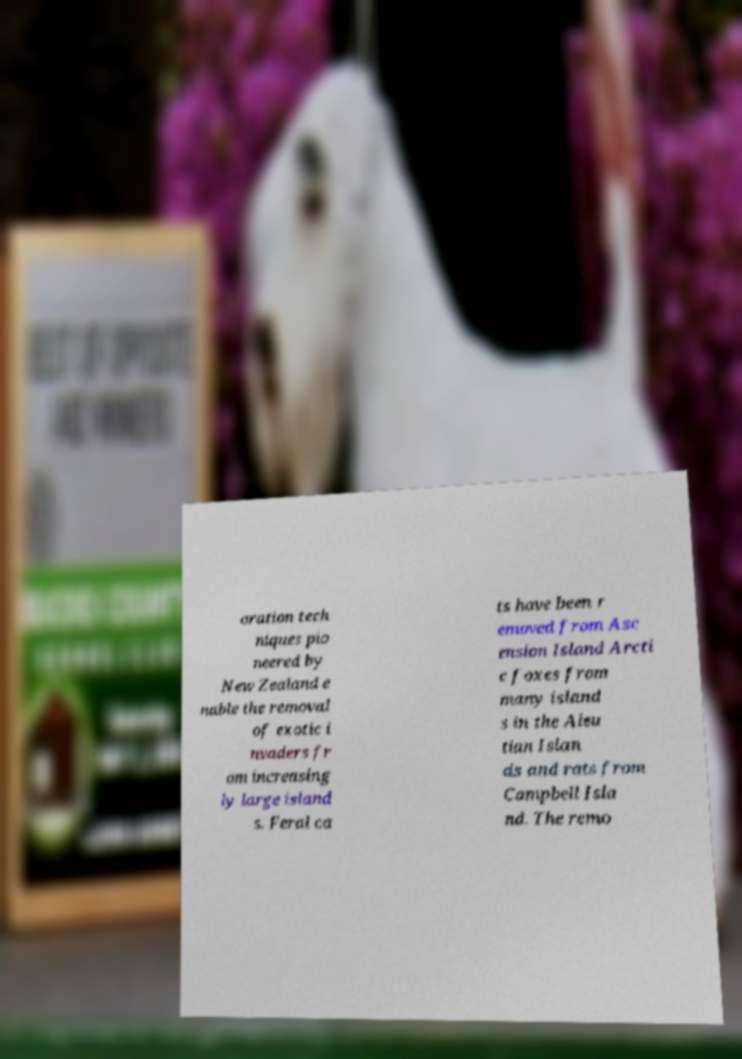For documentation purposes, I need the text within this image transcribed. Could you provide that? oration tech niques pio neered by New Zealand e nable the removal of exotic i nvaders fr om increasing ly large island s. Feral ca ts have been r emoved from Asc ension Island Arcti c foxes from many island s in the Aleu tian Islan ds and rats from Campbell Isla nd. The remo 